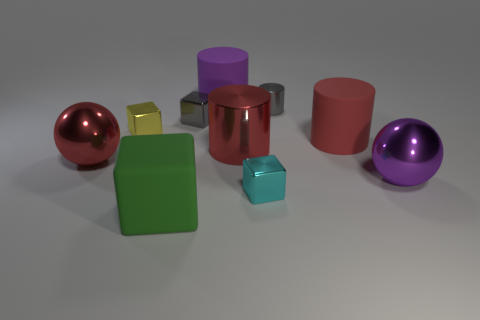What color is the big shiny object that is to the right of the tiny gray cylinder behind the big metallic object in front of the red metal ball?
Your response must be concise. Purple. What number of things are either rubber objects behind the purple metal sphere or big spheres that are right of the red rubber cylinder?
Offer a very short reply. 3. How many other objects are there of the same color as the big metal cylinder?
Offer a terse response. 2. There is a large object in front of the small cyan metallic object; is its shape the same as the purple shiny object?
Ensure brevity in your answer.  No. Is the number of metal balls that are in front of the green cube less than the number of tiny cyan matte cylinders?
Provide a succinct answer. No. Is there a small cyan object that has the same material as the purple cylinder?
Offer a very short reply. No. There is a yellow block that is the same size as the cyan metallic thing; what material is it?
Ensure brevity in your answer.  Metal. Are there fewer big matte things on the left side of the big red metal cylinder than red objects that are to the left of the large matte cube?
Provide a short and direct response. No. There is a rubber object that is in front of the yellow object and to the left of the large red matte thing; what is its shape?
Offer a terse response. Cube. What number of red things are the same shape as the small yellow shiny object?
Provide a succinct answer. 0. 